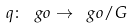Convert formula to latex. <formula><loc_0><loc_0><loc_500><loc_500>q \colon \ g o \rightarrow \ g o / G</formula> 